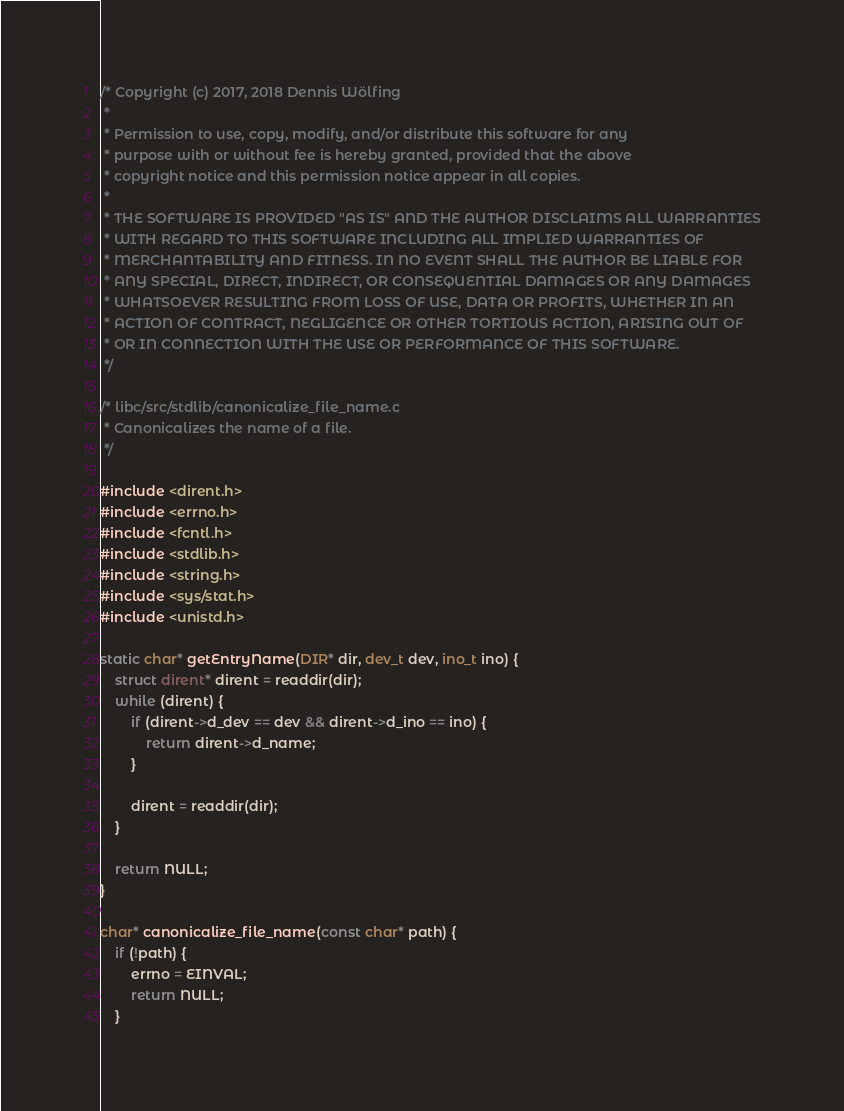Convert code to text. <code><loc_0><loc_0><loc_500><loc_500><_C_>/* Copyright (c) 2017, 2018 Dennis Wölfing
 *
 * Permission to use, copy, modify, and/or distribute this software for any
 * purpose with or without fee is hereby granted, provided that the above
 * copyright notice and this permission notice appear in all copies.
 *
 * THE SOFTWARE IS PROVIDED "AS IS" AND THE AUTHOR DISCLAIMS ALL WARRANTIES
 * WITH REGARD TO THIS SOFTWARE INCLUDING ALL IMPLIED WARRANTIES OF
 * MERCHANTABILITY AND FITNESS. IN NO EVENT SHALL THE AUTHOR BE LIABLE FOR
 * ANY SPECIAL, DIRECT, INDIRECT, OR CONSEQUENTIAL DAMAGES OR ANY DAMAGES
 * WHATSOEVER RESULTING FROM LOSS OF USE, DATA OR PROFITS, WHETHER IN AN
 * ACTION OF CONTRACT, NEGLIGENCE OR OTHER TORTIOUS ACTION, ARISING OUT OF
 * OR IN CONNECTION WITH THE USE OR PERFORMANCE OF THIS SOFTWARE.
 */

/* libc/src/stdlib/canonicalize_file_name.c
 * Canonicalizes the name of a file.
 */

#include <dirent.h>
#include <errno.h>
#include <fcntl.h>
#include <stdlib.h>
#include <string.h>
#include <sys/stat.h>
#include <unistd.h>

static char* getEntryName(DIR* dir, dev_t dev, ino_t ino) {
    struct dirent* dirent = readdir(dir);
    while (dirent) {
        if (dirent->d_dev == dev && dirent->d_ino == ino) {
            return dirent->d_name;
        }

        dirent = readdir(dir);
    }

    return NULL;
}

char* canonicalize_file_name(const char* path) {
    if (!path) {
        errno = EINVAL;
        return NULL;
    }
</code> 